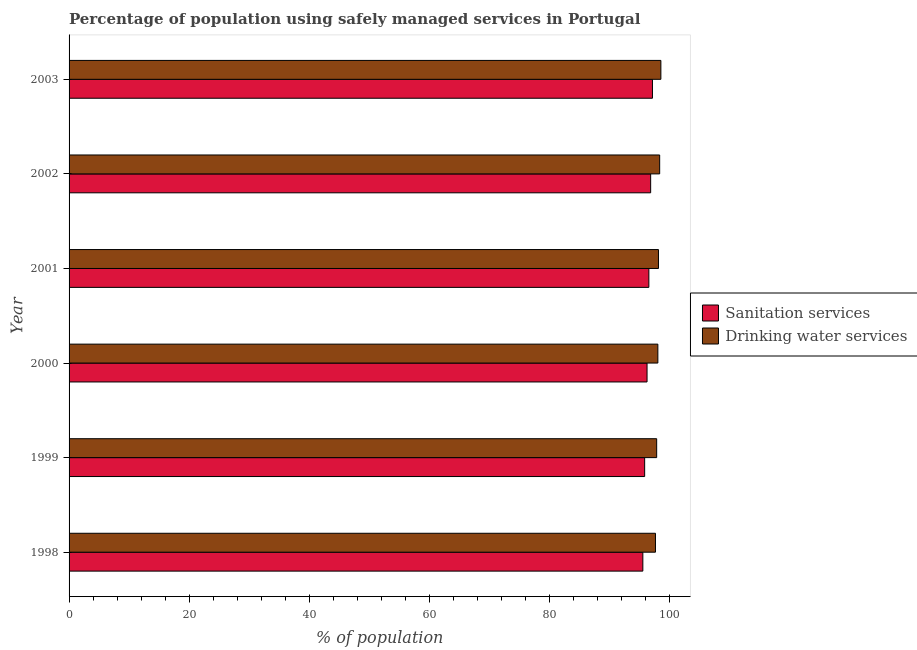Are the number of bars per tick equal to the number of legend labels?
Make the answer very short. Yes. What is the percentage of population who used sanitation services in 1998?
Your response must be concise. 95.5. Across all years, what is the maximum percentage of population who used sanitation services?
Provide a succinct answer. 97.1. Across all years, what is the minimum percentage of population who used drinking water services?
Provide a succinct answer. 97.6. In which year was the percentage of population who used drinking water services maximum?
Provide a short and direct response. 2003. What is the total percentage of population who used drinking water services in the graph?
Your answer should be compact. 588.3. What is the difference between the percentage of population who used drinking water services in 1999 and the percentage of population who used sanitation services in 2000?
Give a very brief answer. 1.6. What is the average percentage of population who used sanitation services per year?
Ensure brevity in your answer.  96.32. Is the difference between the percentage of population who used sanitation services in 2000 and 2003 greater than the difference between the percentage of population who used drinking water services in 2000 and 2003?
Provide a short and direct response. No. What is the difference between the highest and the second highest percentage of population who used sanitation services?
Give a very brief answer. 0.3. What is the difference between the highest and the lowest percentage of population who used drinking water services?
Provide a succinct answer. 0.9. Is the sum of the percentage of population who used sanitation services in 2001 and 2002 greater than the maximum percentage of population who used drinking water services across all years?
Make the answer very short. Yes. What does the 1st bar from the top in 2000 represents?
Give a very brief answer. Drinking water services. What does the 2nd bar from the bottom in 2003 represents?
Keep it short and to the point. Drinking water services. How many bars are there?
Provide a short and direct response. 12. What is the difference between two consecutive major ticks on the X-axis?
Your response must be concise. 20. Where does the legend appear in the graph?
Your response must be concise. Center right. How are the legend labels stacked?
Provide a short and direct response. Vertical. What is the title of the graph?
Ensure brevity in your answer.  Percentage of population using safely managed services in Portugal. What is the label or title of the X-axis?
Offer a terse response. % of population. What is the label or title of the Y-axis?
Give a very brief answer. Year. What is the % of population in Sanitation services in 1998?
Offer a terse response. 95.5. What is the % of population in Drinking water services in 1998?
Offer a very short reply. 97.6. What is the % of population of Sanitation services in 1999?
Offer a terse response. 95.8. What is the % of population of Drinking water services in 1999?
Your answer should be very brief. 97.8. What is the % of population of Sanitation services in 2000?
Offer a terse response. 96.2. What is the % of population of Sanitation services in 2001?
Provide a succinct answer. 96.5. What is the % of population of Drinking water services in 2001?
Ensure brevity in your answer.  98.1. What is the % of population in Sanitation services in 2002?
Your response must be concise. 96.8. What is the % of population in Drinking water services in 2002?
Provide a succinct answer. 98.3. What is the % of population in Sanitation services in 2003?
Your answer should be compact. 97.1. What is the % of population of Drinking water services in 2003?
Your response must be concise. 98.5. Across all years, what is the maximum % of population of Sanitation services?
Provide a short and direct response. 97.1. Across all years, what is the maximum % of population in Drinking water services?
Your response must be concise. 98.5. Across all years, what is the minimum % of population in Sanitation services?
Keep it short and to the point. 95.5. Across all years, what is the minimum % of population in Drinking water services?
Your answer should be compact. 97.6. What is the total % of population in Sanitation services in the graph?
Provide a succinct answer. 577.9. What is the total % of population in Drinking water services in the graph?
Give a very brief answer. 588.3. What is the difference between the % of population of Drinking water services in 1998 and that in 2000?
Your answer should be compact. -0.4. What is the difference between the % of population of Sanitation services in 1998 and that in 2001?
Offer a terse response. -1. What is the difference between the % of population of Sanitation services in 1998 and that in 2002?
Keep it short and to the point. -1.3. What is the difference between the % of population in Drinking water services in 1998 and that in 2002?
Your answer should be compact. -0.7. What is the difference between the % of population in Drinking water services in 1998 and that in 2003?
Offer a terse response. -0.9. What is the difference between the % of population in Drinking water services in 1999 and that in 2000?
Your response must be concise. -0.2. What is the difference between the % of population in Drinking water services in 1999 and that in 2001?
Make the answer very short. -0.3. What is the difference between the % of population of Sanitation services in 1999 and that in 2002?
Your response must be concise. -1. What is the difference between the % of population in Sanitation services in 2000 and that in 2002?
Give a very brief answer. -0.6. What is the difference between the % of population in Sanitation services in 2001 and that in 2002?
Give a very brief answer. -0.3. What is the difference between the % of population in Drinking water services in 2001 and that in 2002?
Keep it short and to the point. -0.2. What is the difference between the % of population of Sanitation services in 2001 and that in 2003?
Keep it short and to the point. -0.6. What is the difference between the % of population in Sanitation services in 1998 and the % of population in Drinking water services in 1999?
Your response must be concise. -2.3. What is the difference between the % of population in Sanitation services in 1998 and the % of population in Drinking water services in 2000?
Offer a very short reply. -2.5. What is the difference between the % of population in Sanitation services in 1998 and the % of population in Drinking water services in 2001?
Ensure brevity in your answer.  -2.6. What is the difference between the % of population of Sanitation services in 1999 and the % of population of Drinking water services in 2000?
Ensure brevity in your answer.  -2.2. What is the difference between the % of population in Sanitation services in 2000 and the % of population in Drinking water services in 2001?
Ensure brevity in your answer.  -1.9. What is the difference between the % of population in Sanitation services in 2000 and the % of population in Drinking water services in 2003?
Offer a very short reply. -2.3. What is the difference between the % of population of Sanitation services in 2001 and the % of population of Drinking water services in 2002?
Your response must be concise. -1.8. What is the difference between the % of population in Sanitation services in 2001 and the % of population in Drinking water services in 2003?
Make the answer very short. -2. What is the difference between the % of population of Sanitation services in 2002 and the % of population of Drinking water services in 2003?
Offer a terse response. -1.7. What is the average % of population in Sanitation services per year?
Your response must be concise. 96.32. What is the average % of population of Drinking water services per year?
Offer a terse response. 98.05. In the year 1999, what is the difference between the % of population of Sanitation services and % of population of Drinking water services?
Provide a succinct answer. -2. In the year 2002, what is the difference between the % of population in Sanitation services and % of population in Drinking water services?
Make the answer very short. -1.5. What is the ratio of the % of population in Sanitation services in 1998 to that in 2000?
Offer a terse response. 0.99. What is the ratio of the % of population in Drinking water services in 1998 to that in 2000?
Provide a succinct answer. 1. What is the ratio of the % of population of Sanitation services in 1998 to that in 2001?
Your answer should be very brief. 0.99. What is the ratio of the % of population of Drinking water services in 1998 to that in 2001?
Provide a succinct answer. 0.99. What is the ratio of the % of population of Sanitation services in 1998 to that in 2002?
Offer a very short reply. 0.99. What is the ratio of the % of population in Drinking water services in 1998 to that in 2002?
Ensure brevity in your answer.  0.99. What is the ratio of the % of population of Sanitation services in 1998 to that in 2003?
Your answer should be compact. 0.98. What is the ratio of the % of population in Drinking water services in 1998 to that in 2003?
Keep it short and to the point. 0.99. What is the ratio of the % of population in Drinking water services in 1999 to that in 2000?
Provide a succinct answer. 1. What is the ratio of the % of population in Drinking water services in 1999 to that in 2001?
Provide a succinct answer. 1. What is the ratio of the % of population of Sanitation services in 1999 to that in 2002?
Ensure brevity in your answer.  0.99. What is the ratio of the % of population in Drinking water services in 1999 to that in 2002?
Your answer should be very brief. 0.99. What is the ratio of the % of population in Sanitation services in 1999 to that in 2003?
Provide a succinct answer. 0.99. What is the ratio of the % of population of Sanitation services in 2000 to that in 2001?
Offer a terse response. 1. What is the ratio of the % of population in Drinking water services in 2000 to that in 2001?
Ensure brevity in your answer.  1. What is the ratio of the % of population in Sanitation services in 2000 to that in 2002?
Provide a succinct answer. 0.99. What is the ratio of the % of population in Sanitation services in 2000 to that in 2003?
Offer a very short reply. 0.99. What is the ratio of the % of population in Sanitation services in 2001 to that in 2002?
Ensure brevity in your answer.  1. What is the ratio of the % of population in Drinking water services in 2001 to that in 2002?
Provide a short and direct response. 1. What is the ratio of the % of population of Sanitation services in 2001 to that in 2003?
Provide a succinct answer. 0.99. What is the ratio of the % of population of Sanitation services in 2002 to that in 2003?
Give a very brief answer. 1. What is the ratio of the % of population of Drinking water services in 2002 to that in 2003?
Offer a very short reply. 1. What is the difference between the highest and the second highest % of population of Sanitation services?
Provide a succinct answer. 0.3. What is the difference between the highest and the lowest % of population of Drinking water services?
Your response must be concise. 0.9. 